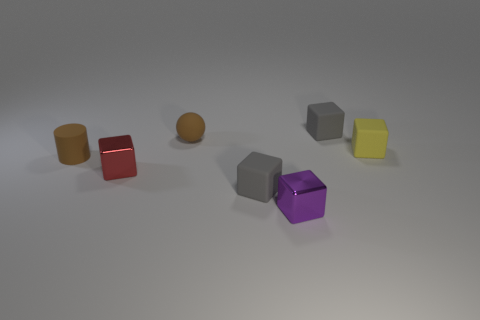Is the small matte cylinder the same color as the sphere?
Offer a very short reply. Yes. How many things are large blue objects or brown things that are behind the brown cylinder?
Your answer should be compact. 1. There is a tiny thing that is the same color as the rubber ball; what shape is it?
Provide a short and direct response. Cylinder. The matte block that is in front of the yellow matte block is what color?
Your answer should be compact. Gray. How many objects are either objects behind the tiny matte ball or tiny metal blocks?
Give a very brief answer. 3. There is another metallic cube that is the same size as the purple metal cube; what color is it?
Your answer should be very brief. Red. Is the number of rubber things that are to the left of the tiny purple object greater than the number of small rubber spheres?
Give a very brief answer. Yes. The tiny object that is in front of the rubber cylinder and left of the small matte sphere is made of what material?
Make the answer very short. Metal. There is a small matte block left of the tiny purple metal cube; does it have the same color as the small cube that is behind the yellow block?
Give a very brief answer. Yes. How many other things are there of the same size as the purple thing?
Your answer should be very brief. 6. 